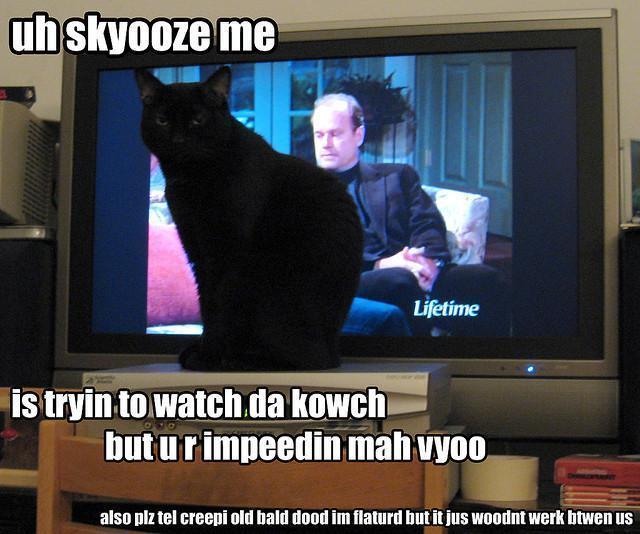What piece of furniture is misspelled here?
From the following set of four choices, select the accurate answer to respond to the question.
Options: Bed, table, stool, couch. Couch. 